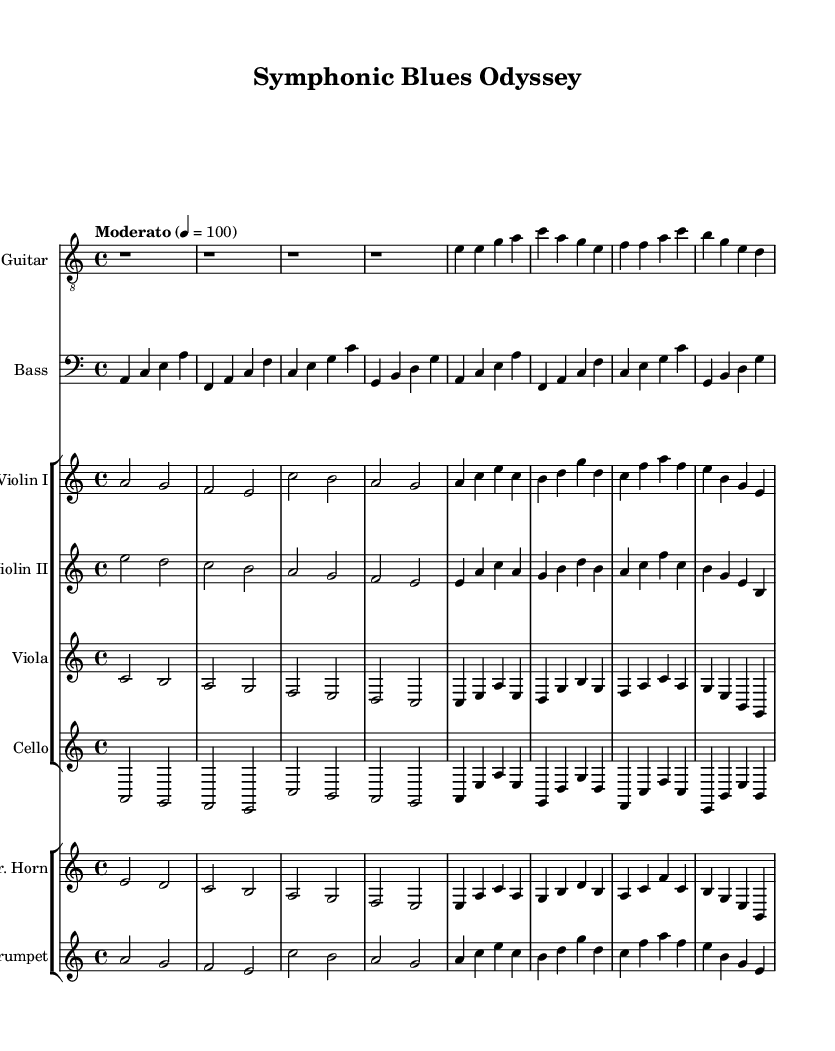What is the key signature of this music? The key signature indicates two flats, which corresponds to the key of A minor.
Answer: A minor What is the time signature of this music? The time signature is found at the beginning of the score, indicating there are four beats per measure.
Answer: 4/4 What is the tempo marking of the piece? The tempo marking "Moderato" indicates a moderate speed, and the metronome marking 4 = 100 suggests 100 beats per minute.
Answer: Moderato Which instrument is playing the melody in the opening section? The electric guitar plays the melody as indicated in the treble staff, showing the primary melodic line for this music.
Answer: Electric Guitar How many string instruments are featured in the orchestration? There are four string instruments specified: Violin I, Violin II, Viola, and Cello. This highlights the use of strings to provide orchestral depth to the electric blues genre.
Answer: Four What type of harmony is expected in blues-rock music like this? The harmonic structure typically features dominant chords and blues progressions, which are fundamental to blues music, suggesting a strong influence of the blues genre on this orchestral arrangement.
Answer: Dominant chords What is the role of the brass section in this arrangement? The brass section, comprising French Horn and Trumpet, adds color and volume to the orchestral texture, likely enhancing the emotional intensity characteristically found in blues-rock crossover pieces.
Answer: Color and volume 